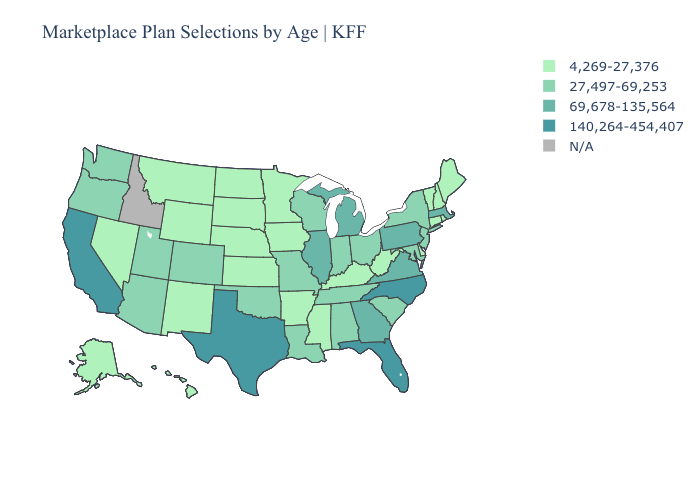Which states have the highest value in the USA?
Short answer required. California, Florida, North Carolina, Texas. Name the states that have a value in the range 27,497-69,253?
Concise answer only. Alabama, Arizona, Colorado, Indiana, Louisiana, Maryland, Missouri, New Jersey, New York, Ohio, Oklahoma, Oregon, South Carolina, Tennessee, Utah, Washington, Wisconsin. What is the lowest value in the Northeast?
Write a very short answer. 4,269-27,376. Name the states that have a value in the range 27,497-69,253?
Give a very brief answer. Alabama, Arizona, Colorado, Indiana, Louisiana, Maryland, Missouri, New Jersey, New York, Ohio, Oklahoma, Oregon, South Carolina, Tennessee, Utah, Washington, Wisconsin. Name the states that have a value in the range 69,678-135,564?
Short answer required. Georgia, Illinois, Massachusetts, Michigan, Pennsylvania, Virginia. What is the value of South Carolina?
Be succinct. 27,497-69,253. What is the lowest value in states that border West Virginia?
Give a very brief answer. 4,269-27,376. Name the states that have a value in the range 140,264-454,407?
Quick response, please. California, Florida, North Carolina, Texas. Name the states that have a value in the range 69,678-135,564?
Be succinct. Georgia, Illinois, Massachusetts, Michigan, Pennsylvania, Virginia. Does the map have missing data?
Short answer required. Yes. What is the value of Louisiana?
Answer briefly. 27,497-69,253. Name the states that have a value in the range N/A?
Write a very short answer. Idaho. Which states have the highest value in the USA?
Keep it brief. California, Florida, North Carolina, Texas. Name the states that have a value in the range 69,678-135,564?
Give a very brief answer. Georgia, Illinois, Massachusetts, Michigan, Pennsylvania, Virginia. 